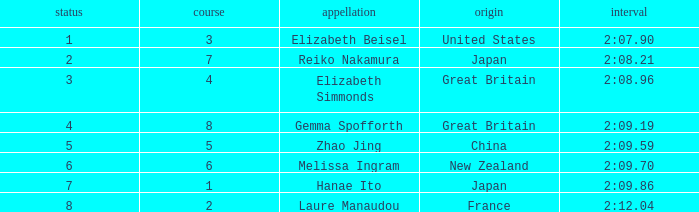What is Elizabeth Simmonds' average lane number? 4.0. Write the full table. {'header': ['status', 'course', 'appellation', 'origin', 'interval'], 'rows': [['1', '3', 'Elizabeth Beisel', 'United States', '2:07.90'], ['2', '7', 'Reiko Nakamura', 'Japan', '2:08.21'], ['3', '4', 'Elizabeth Simmonds', 'Great Britain', '2:08.96'], ['4', '8', 'Gemma Spofforth', 'Great Britain', '2:09.19'], ['5', '5', 'Zhao Jing', 'China', '2:09.59'], ['6', '6', 'Melissa Ingram', 'New Zealand', '2:09.70'], ['7', '1', 'Hanae Ito', 'Japan', '2:09.86'], ['8', '2', 'Laure Manaudou', 'France', '2:12.04']]} 